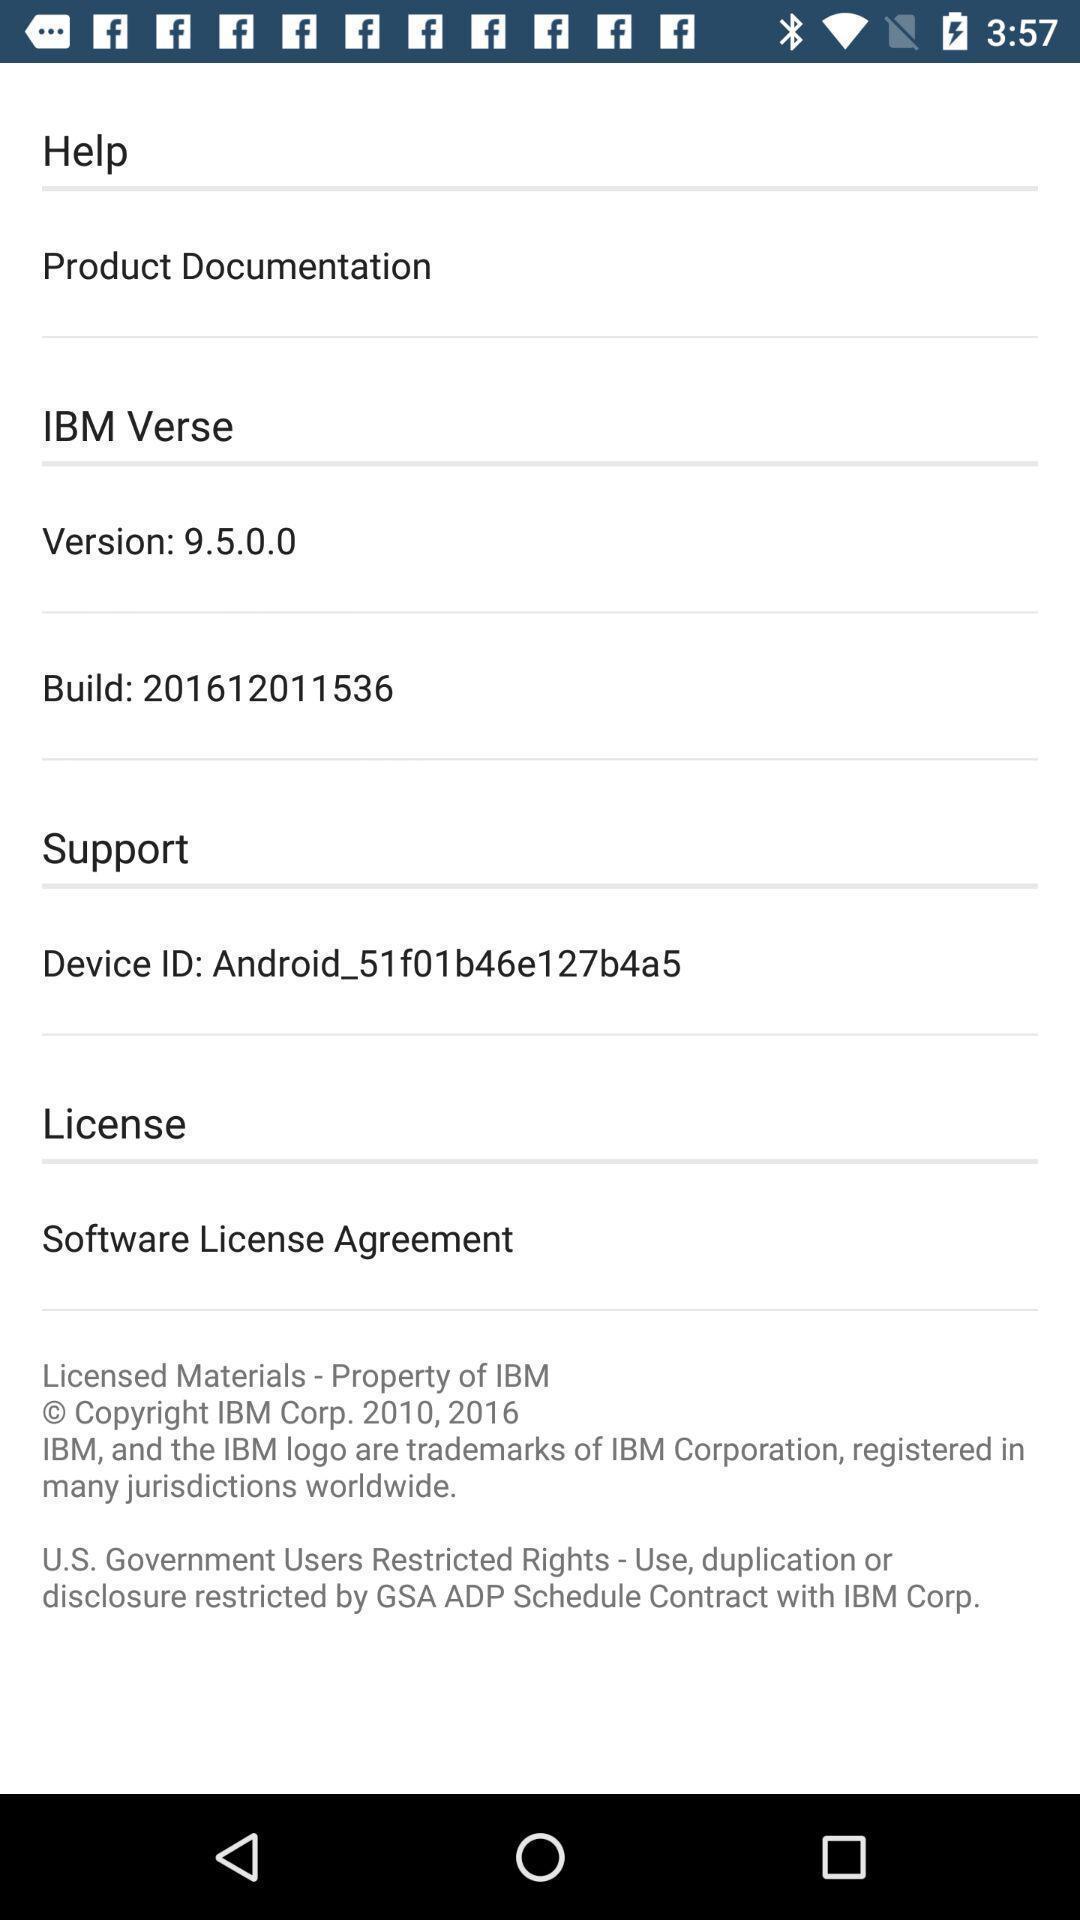Describe this image in words. Screen displaying the screen page. 